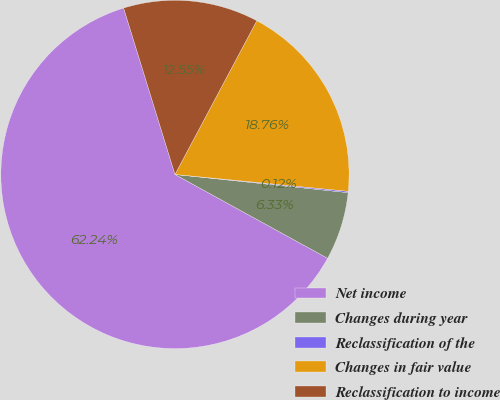Convert chart to OTSL. <chart><loc_0><loc_0><loc_500><loc_500><pie_chart><fcel>Net income<fcel>Changes during year<fcel>Reclassification of the<fcel>Changes in fair value<fcel>Reclassification to income<nl><fcel>62.24%<fcel>6.33%<fcel>0.12%<fcel>18.76%<fcel>12.55%<nl></chart> 